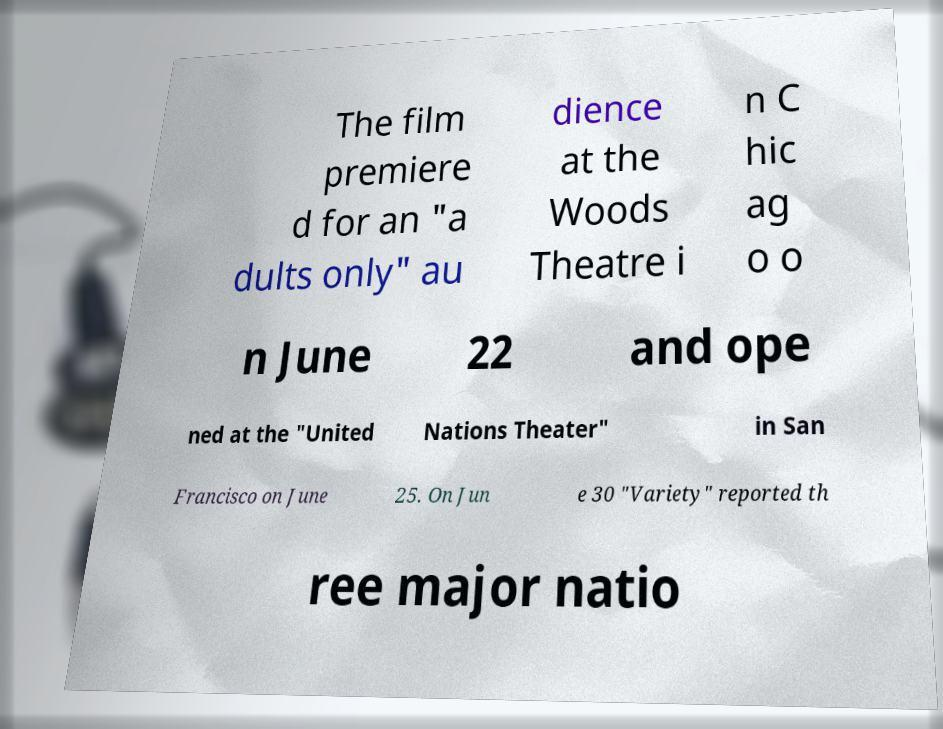Could you extract and type out the text from this image? The film premiere d for an "a dults only" au dience at the Woods Theatre i n C hic ag o o n June 22 and ope ned at the "United Nations Theater" in San Francisco on June 25. On Jun e 30 "Variety" reported th ree major natio 